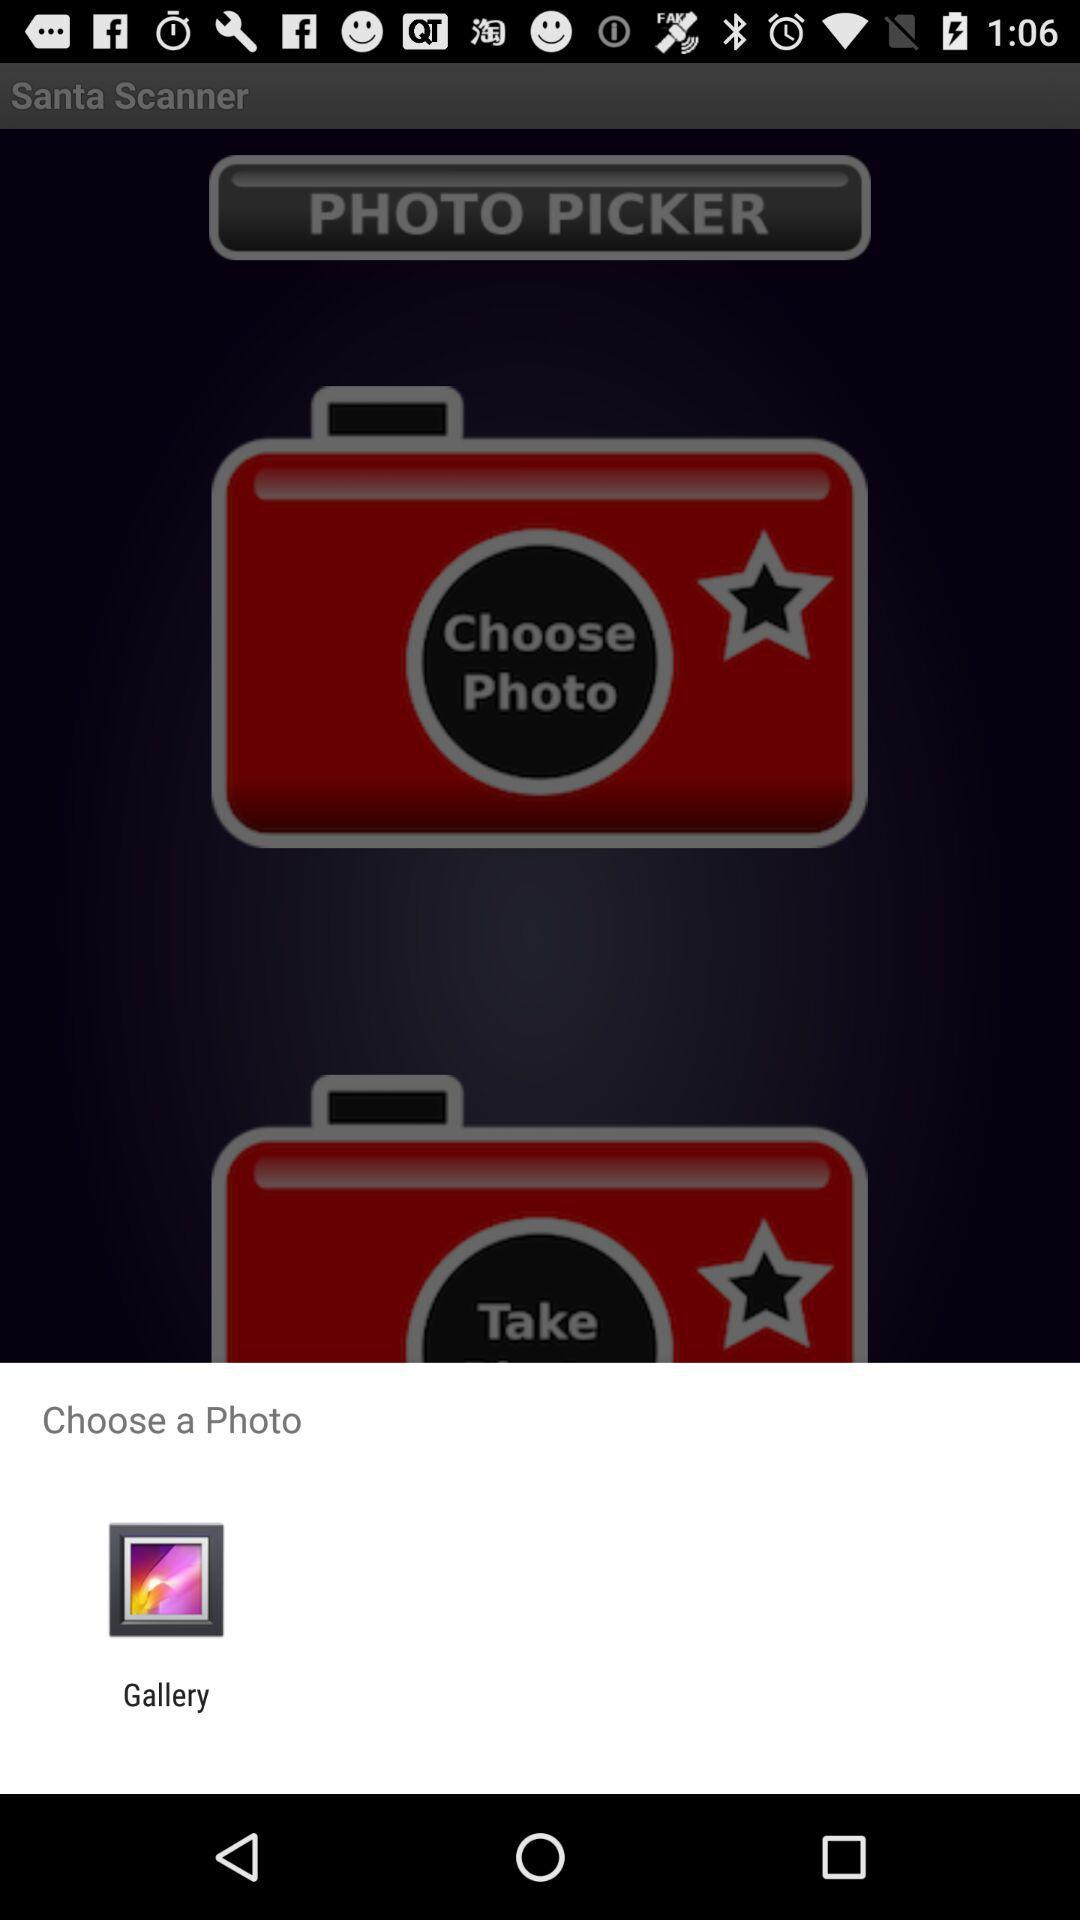Through which application can the photo be chosen? The photo can be chosen through "Gallery". 